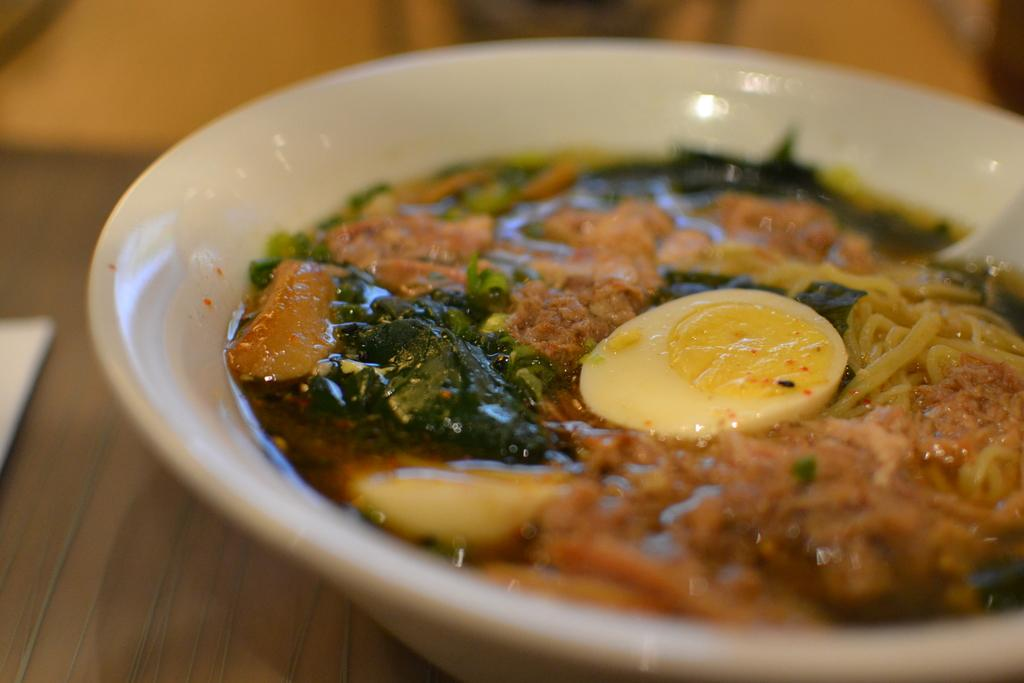What color is the bowl in the image? The bowl in the image is white. What is inside the bowl? The bowl contains food. On what surface is the bowl placed? The bowl is placed on a brown table. Can you describe the background of the image? The background of the image is blurred. How many mittens are visible in the image? There are no mittens present in the image. What is the size of the bowl in the image? The size of the bowl cannot be determined from the image alone, as there is no reference for scale. 